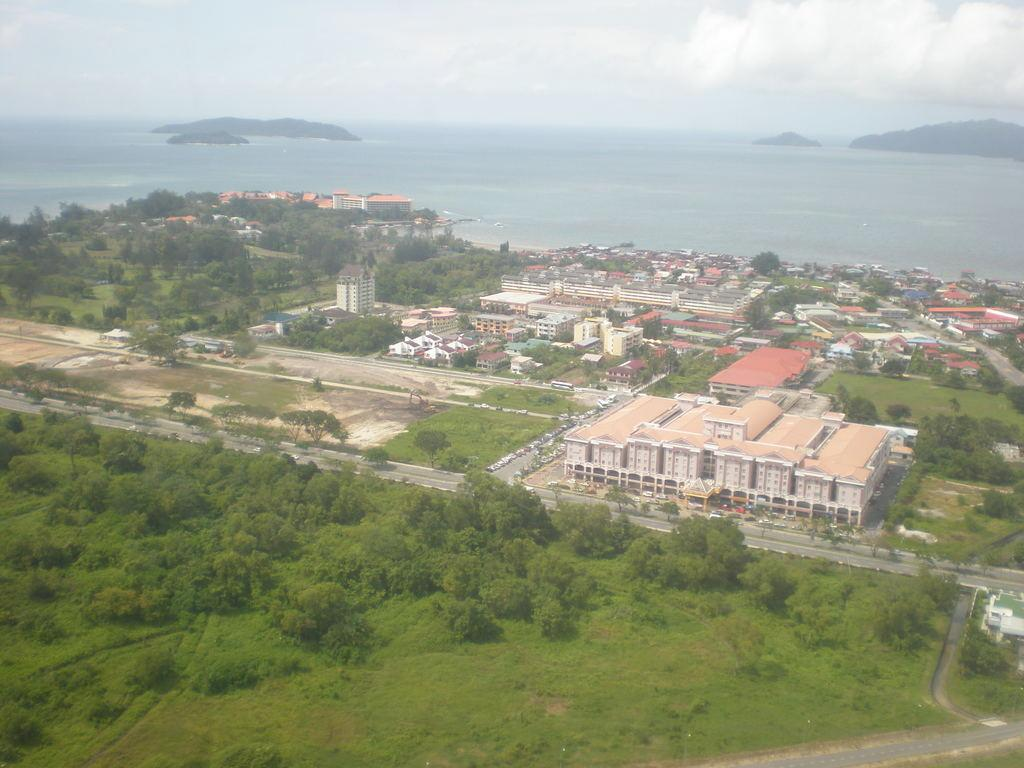What type of view is shown in the image? The image is an aerial view. What types of structures can be seen in the image? There are buildings and houses in the image. What natural elements are present in the image? There are trees, a sea, and mountains in the image. What man-made structures are visible in the image? There are roads in the image. Where is the dime placed on the stage in the image? There is no dime or stage present in the image. What type of doll is sitting on the mountain in the image? There is no doll present in the image. 